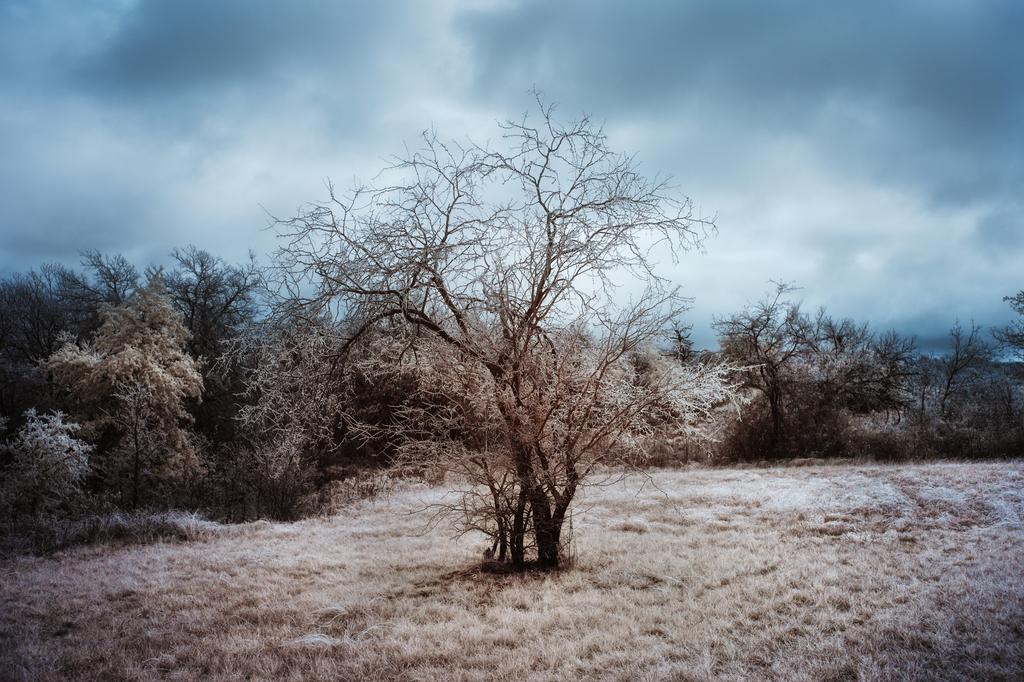What type of vegetation can be seen in the image? There are dry trees in the image. What is on the ground in the image? There is dry grass on the ground in the image. What invention is being demonstrated in the image? There is no invention being demonstrated in the image; it features dry trees and dry grass. How many kittens can be seen playing in the image? There are no kittens present in the image. 